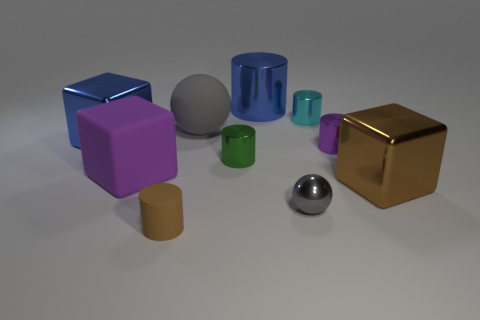Are there any tiny balls?
Keep it short and to the point. Yes. There is a gray ball in front of the large shiny block that is to the left of the large purple matte cube; what is its size?
Your answer should be compact. Small. Are there more cyan cylinders in front of the big matte cube than brown things behind the large gray thing?
Ensure brevity in your answer.  No. What number of blocks are either small gray metal things or small cyan metallic things?
Offer a terse response. 0. Is there anything else that has the same size as the blue metallic cylinder?
Ensure brevity in your answer.  Yes. Do the metallic thing to the right of the purple metal cylinder and the brown matte thing have the same shape?
Provide a short and direct response. No. What color is the tiny ball?
Provide a succinct answer. Gray. What is the color of the other matte object that is the same shape as the green object?
Offer a terse response. Brown. What number of blue things have the same shape as the large purple rubber thing?
Your response must be concise. 1. How many objects are either small spheres or tiny cylinders on the right side of the tiny brown cylinder?
Your answer should be compact. 4. 